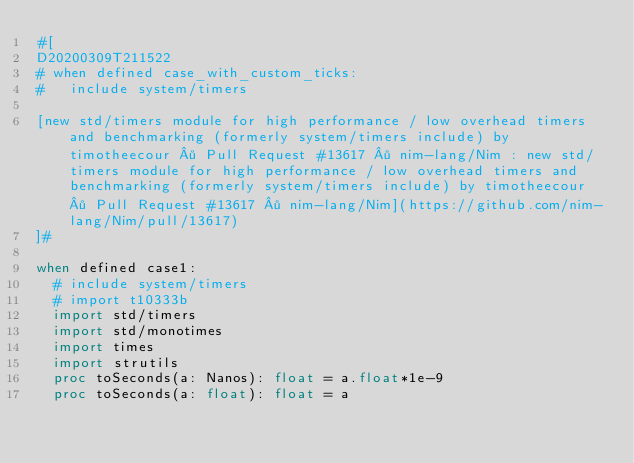Convert code to text. <code><loc_0><loc_0><loc_500><loc_500><_Nim_>#[
D20200309T211522
# when defined case_with_custom_ticks:
#   include system/timers

[new std/timers module for high performance / low overhead timers and benchmarking (formerly system/timers include) by timotheecour · Pull Request #13617 · nim-lang/Nim : new std/timers module for high performance / low overhead timers and benchmarking (formerly system/timers include) by timotheecour · Pull Request #13617 · nim-lang/Nim](https://github.com/nim-lang/Nim/pull/13617)
]#

when defined case1:
  # include system/timers
  # import t10333b
  import std/timers
  import std/monotimes
  import times
  import strutils
  proc toSeconds(a: Nanos): float = a.float*1e-9
  proc toSeconds(a: float): float = a</code> 